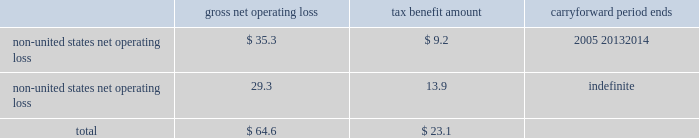Edwards lifesciences corporation notes to consolidated financial statements 2014 ( continued ) as of december 31 , 2004 , the company has approximately $ 64.6 million of non-united states tax net operating losses and $ 1.0 million of non-united states , non-expiring tax credits that are available for carryforward .
Net operating loss carryforwards , and the related carryforward periods , at december 31 , 2004 are summarized as follows ( in millions ) : gross net tax benefit carryforward operating loss amount period ends non-united states net operating loss****************** $ 35.3 $ 9.2 2005 20132014 non-united states net operating loss****************** 29.3 13.9 indefinite total ******************************************** $ 64.6 $ 23.1 a valuation allowance of $ 6.8 million has been provided for certain of the above carryforwards .
This valuation allowance reduces the deferred tax asset of $ 23.1 million to an amount that is more likely than not to be realized .
The company 2019s income tax returns in several locations are being examined by the local taxation authorities .
Management believes that adequate amounts of tax and related interest , if any , have been provided for any adjustments that may result from these examinations .
17 .
Legal proceedings on june 29 , 2000 , edwards lifesciences filed a lawsuit against st .
Jude medical , inc .
Alleging infringement of several edwards lifesciences united states patents .
This lawsuit was filed in the united states district court for the central district of california , seeking monetary damages and injunctive relief .
Pursuant to the terms of a january 7 , 2005 settlement agreement , edwards lifesciences was paid $ 5.5 million by st .
Jude , edwards lifesciences granted st .
Jude a paid-up license for certain of its heart valve therapy products and the lawsuit was dismissed .
The settlement will not have a material financial impact on the company .
On august 18 , 2003 , edwards lifesciences filed a lawsuit against medtronic , inc. , medtronic ave , cook , inc .
And w.l .
Gore & associates alleging infringement of a patent exclusively licensed to the company .
The lawsuit was filed in the united states district court for the northern district of california , seeking monetary damages and injunctive relief .
On september 2 , 2003 , a second patent exclusively licensed to the company was added to the lawsuit .
Each of the defendants has answered and asserted various affirmative defenses and counterclaims .
Discovery is proceeding .
In addition , edwards lifesciences is or may be a party to , or may be otherwise responsible for , pending or threatened lawsuits related primarily to products and services currently or formerly manufactured or performed , as applicable , by edwards lifesciences .
Such cases and claims raise difficult and complex factual and legal issues and are subject to many uncertainties and complexities , including , but not limited to , the facts and circumstances of each particular case or claim , the jurisdiction in which each suit is brought , and differences in applicable law .
Upon resolution of any pending legal matters , edwards lifesciences may incur charges in excess of presently established reserves .
While any such charge could have a material adverse impact on edwards lifesciences 2019 net income or cash flows in the period in which it is recorded or paid , management does not believe that any such charge would have a material adverse effect on edwards lifesciences 2019 financial position , results of operations or liquidity .
Edwards lifesciences is also subject to various environmental laws and regulations both within and outside of the united states .
The operations of edwards lifesciences , like those of other medical device companies , involve the use of substances regulated under environmental laws , primarily in manufacturing and sterilization processes .
While it is difficult to quantify the potential impact of compliance with environmental protection laws .
Edwards lifesciences corporation notes to consolidated financial statements 2014 ( continued ) as of december 31 , 2004 , the company has approximately $ 64.6 million of non-united states tax net operating losses and $ 1.0 million of non-united states , non-expiring tax credits that are available for carryforward .
Net operating loss carryforwards , and the related carryforward periods , at december 31 , 2004 are summarized as follows ( in millions ) : gross net tax benefit carryforward operating loss amount period ends non-united states net operating loss****************** $ 35.3 $ 9.2 2005 20132014 non-united states net operating loss****************** 29.3 13.9 indefinite total ******************************************** $ 64.6 $ 23.1 a valuation allowance of $ 6.8 million has been provided for certain of the above carryforwards .
This valuation allowance reduces the deferred tax asset of $ 23.1 million to an amount that is more likely than not to be realized .
The company 2019s income tax returns in several locations are being examined by the local taxation authorities .
Management believes that adequate amounts of tax and related interest , if any , have been provided for any adjustments that may result from these examinations .
17 .
Legal proceedings on june 29 , 2000 , edwards lifesciences filed a lawsuit against st .
Jude medical , inc .
Alleging infringement of several edwards lifesciences united states patents .
This lawsuit was filed in the united states district court for the central district of california , seeking monetary damages and injunctive relief .
Pursuant to the terms of a january 7 , 2005 settlement agreement , edwards lifesciences was paid $ 5.5 million by st .
Jude , edwards lifesciences granted st .
Jude a paid-up license for certain of its heart valve therapy products and the lawsuit was dismissed .
The settlement will not have a material financial impact on the company .
On august 18 , 2003 , edwards lifesciences filed a lawsuit against medtronic , inc. , medtronic ave , cook , inc .
And w.l .
Gore & associates alleging infringement of a patent exclusively licensed to the company .
The lawsuit was filed in the united states district court for the northern district of california , seeking monetary damages and injunctive relief .
On september 2 , 2003 , a second patent exclusively licensed to the company was added to the lawsuit .
Each of the defendants has answered and asserted various affirmative defenses and counterclaims .
Discovery is proceeding .
In addition , edwards lifesciences is or may be a party to , or may be otherwise responsible for , pending or threatened lawsuits related primarily to products and services currently or formerly manufactured or performed , as applicable , by edwards lifesciences .
Such cases and claims raise difficult and complex factual and legal issues and are subject to many uncertainties and complexities , including , but not limited to , the facts and circumstances of each particular case or claim , the jurisdiction in which each suit is brought , and differences in applicable law .
Upon resolution of any pending legal matters , edwards lifesciences may incur charges in excess of presently established reserves .
While any such charge could have a material adverse impact on edwards lifesciences 2019 net income or cash flows in the period in which it is recorded or paid , management does not believe that any such charge would have a material adverse effect on edwards lifesciences 2019 financial position , results of operations or liquidity .
Edwards lifesciences is also subject to various environmental laws and regulations both within and outside of the united states .
The operations of edwards lifesciences , like those of other medical device companies , involve the use of substances regulated under environmental laws , primarily in manufacturing and sterilization processes .
While it is difficult to quantify the potential impact of compliance with environmental protection laws .
What is the percentage of the tax benefit compared to the gross net operating loss for the non-united states net operating loss from 2005 -2014? 
Computations: (9.2 / 35.3)
Answer: 0.26062. 